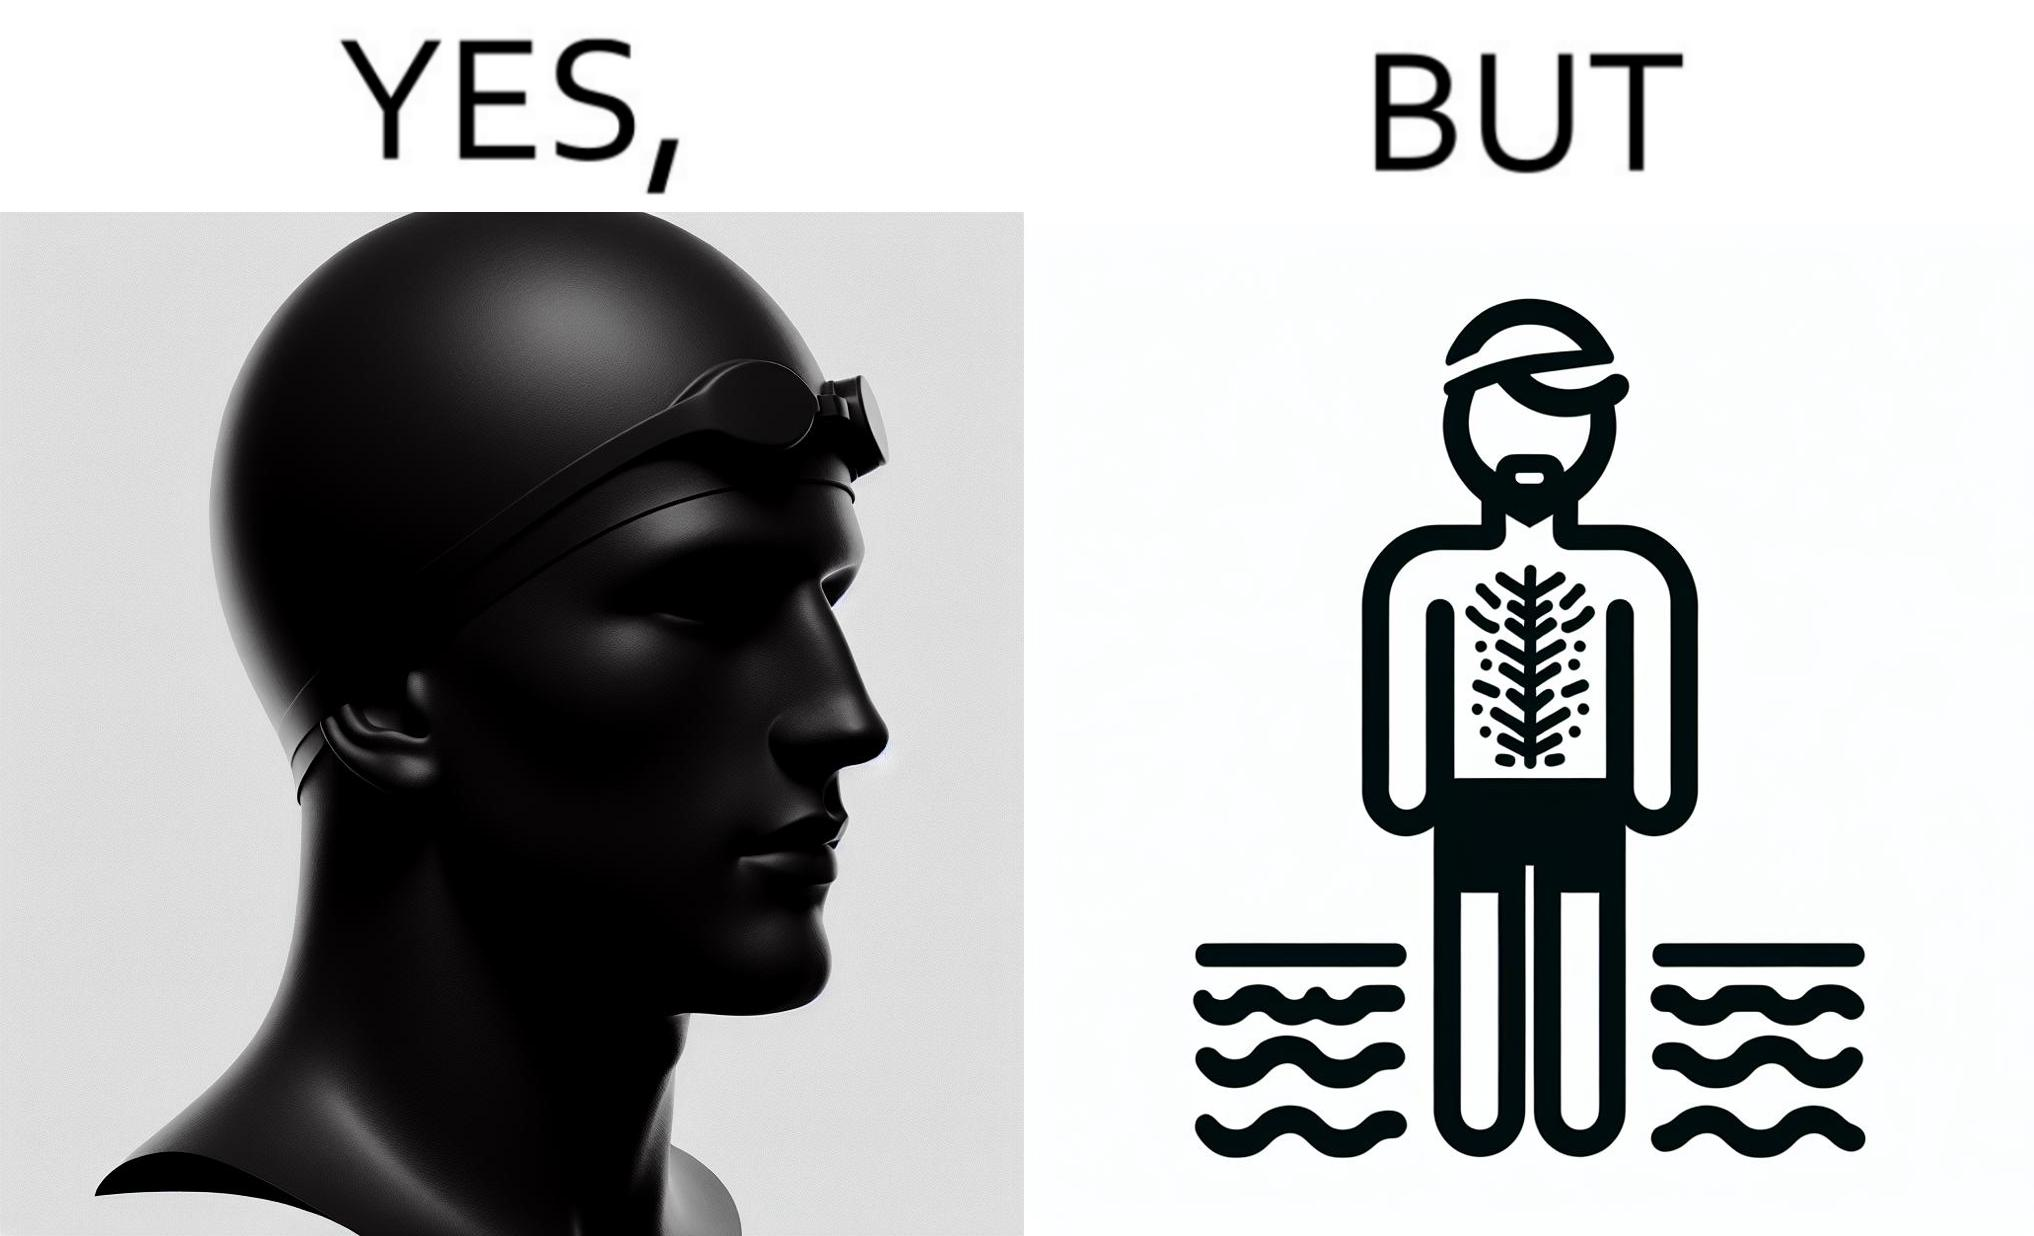What do you see in each half of this image? In the left part of the image: a person's face is shown wearing some cap, probably swimming cap In the right part of the image: a person in shorts wearing a swimming cap standing near some water body, having beard and hairs all over his body 